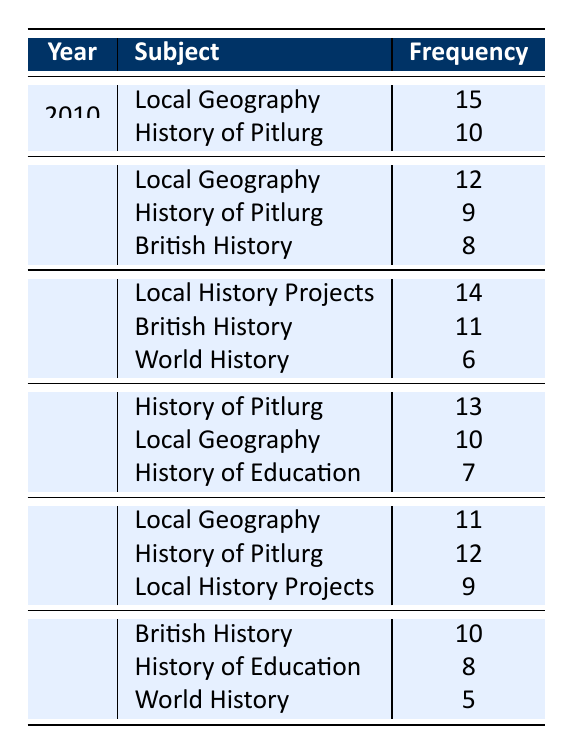What is the frequency of "Local Geography" in 2010? The table shows the entry for "Local Geography" under the year 2010, which states a frequency of 15.
Answer: 15 How many subjects were taught in 2011? In 2011, there are three subjects listed: "Local Geography," "History of Pitlurg," and "British History." Therefore, the total count of subjects taught is 3.
Answer: 3 What is the total frequency of all subjects taught in 2012? To find the total for 2012, I add the frequencies: 14 (Local History Projects) + 11 (British History) + 6 (World History) = 31.
Answer: 31 In which year was "History of Pitlurg" taught the most frequently? The frequencies for "History of Pitlurg" are: 10 in 2010, 9 in 2011, 13 in 2013, 12 in 2014. The highest frequency is 13 in 2013.
Answer: 2013 Is "World History" taught every year from 2010 to 2015? "World History" appears only in 2012 and 2015 with frequencies of 6 and 5 respectively. It is not taught in 2010, 2011, 2013, or 2014. Therefore, the statement is false.
Answer: No What was the average frequency of "British History" across the years it was taught? "British History" was taught in 2011 (8), 2012 (11), and 2015 (10). The average frequency is calculated as (8 + 11 + 10) / 3 = 29 / 3 = 9.67.
Answer: 9.67 Which subject had the highest overall frequency across all years? I will sum the frequencies for each subject: "Local Geography" totals 48, "History of Pitlurg" totals 44, "British History" totals 29, "Local History Projects" totals 23, "World History" totals 11, and "History of Education" totals 15. The highest is "Local Geography" with 48.
Answer: Local Geography How many totals are there for “Local History Projects”? There are two frequencies listed for "Local History Projects": 14 in 2012 and 9 in 2014. So, the total is 14 + 9 = 23.
Answer: 23 Did any subjects increase in frequency between consecutive years? Checking year-by-year, "History of Pitlurg" increased from 9 in 2011 to 13 in 2013, and "Local Geography" increased from 10 in 2013 to 11 in 2014. This confirms that there were increases.
Answer: Yes 